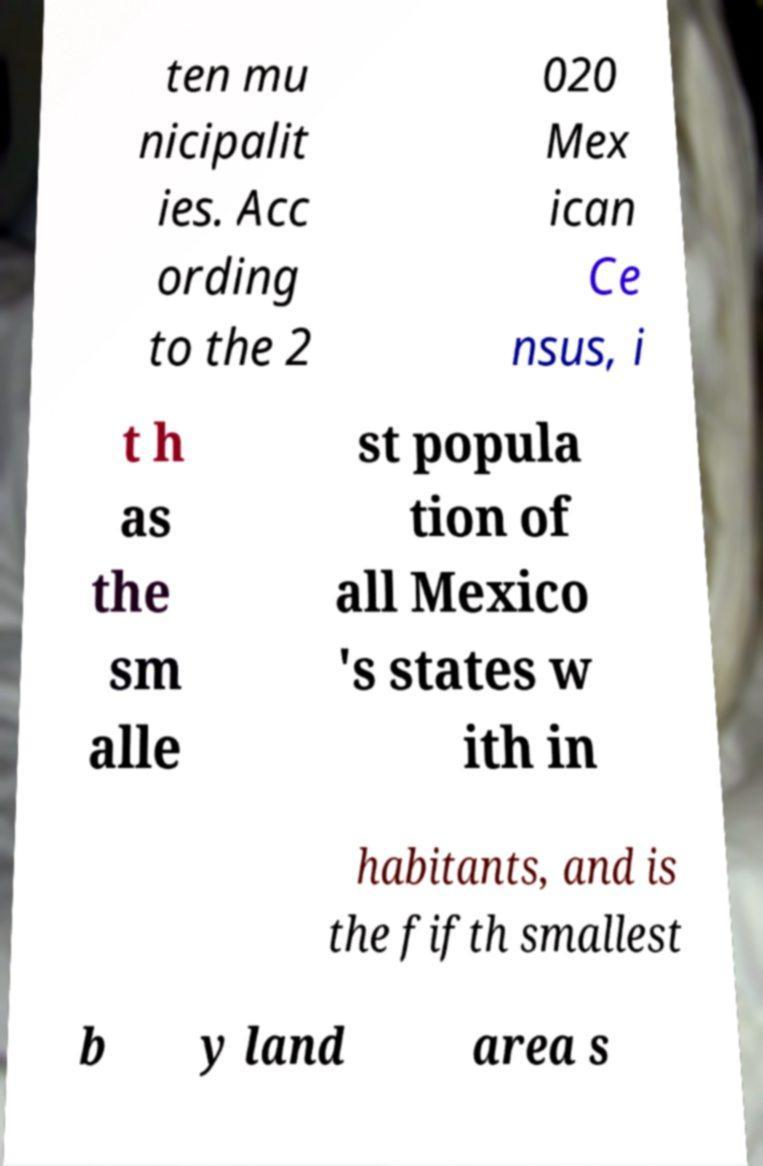Can you accurately transcribe the text from the provided image for me? ten mu nicipalit ies. Acc ording to the 2 020 Mex ican Ce nsus, i t h as the sm alle st popula tion of all Mexico 's states w ith in habitants, and is the fifth smallest b y land area s 